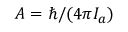<formula> <loc_0><loc_0><loc_500><loc_500>A = \hbar { / } ( 4 \pi I _ { a } )</formula> 